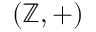<formula> <loc_0><loc_0><loc_500><loc_500>\left ( \mathbb { Z } , + \right )</formula> 